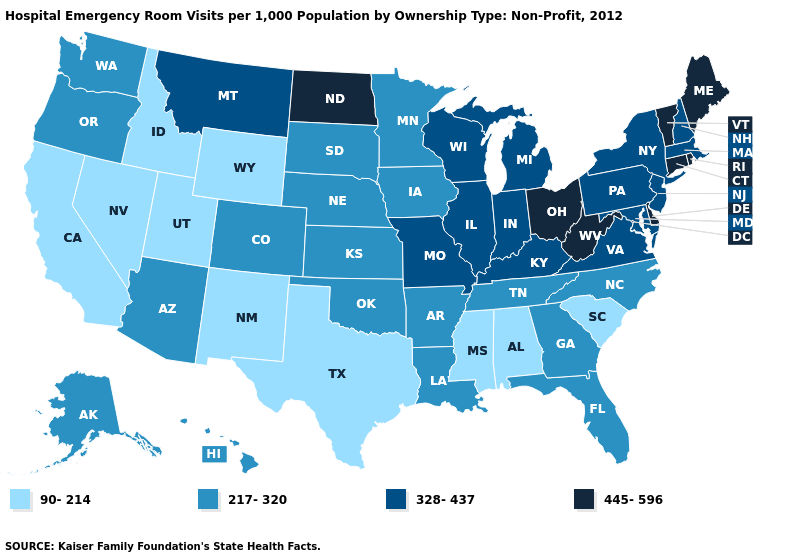Does the map have missing data?
Be succinct. No. Does the map have missing data?
Short answer required. No. Name the states that have a value in the range 328-437?
Quick response, please. Illinois, Indiana, Kentucky, Maryland, Massachusetts, Michigan, Missouri, Montana, New Hampshire, New Jersey, New York, Pennsylvania, Virginia, Wisconsin. Does Indiana have the lowest value in the MidWest?
Concise answer only. No. Is the legend a continuous bar?
Quick response, please. No. Among the states that border Nebraska , which have the highest value?
Concise answer only. Missouri. Name the states that have a value in the range 217-320?
Answer briefly. Alaska, Arizona, Arkansas, Colorado, Florida, Georgia, Hawaii, Iowa, Kansas, Louisiana, Minnesota, Nebraska, North Carolina, Oklahoma, Oregon, South Dakota, Tennessee, Washington. Does Alaska have the highest value in the USA?
Keep it brief. No. What is the value of Tennessee?
Keep it brief. 217-320. What is the lowest value in the South?
Quick response, please. 90-214. Name the states that have a value in the range 445-596?
Answer briefly. Connecticut, Delaware, Maine, North Dakota, Ohio, Rhode Island, Vermont, West Virginia. Does Wyoming have the lowest value in the USA?
Quick response, please. Yes. What is the value of Alaska?
Answer briefly. 217-320. What is the value of Wisconsin?
Concise answer only. 328-437. Is the legend a continuous bar?
Write a very short answer. No. 